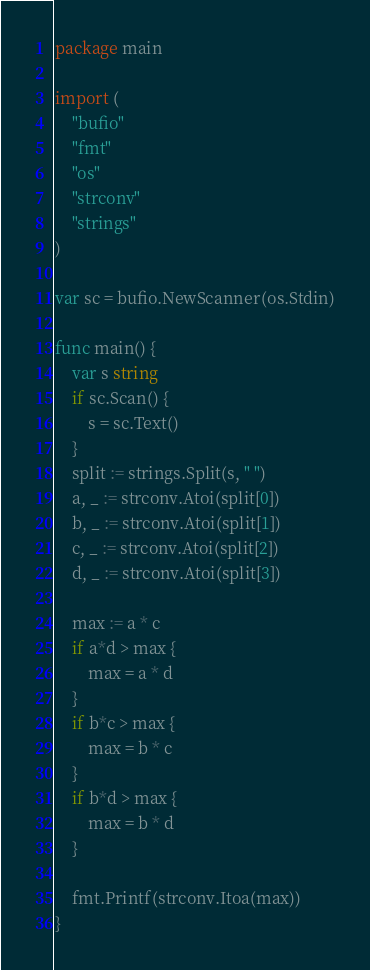Convert code to text. <code><loc_0><loc_0><loc_500><loc_500><_Go_>package main

import (
	"bufio"
	"fmt"
	"os"
	"strconv"
	"strings"
)

var sc = bufio.NewScanner(os.Stdin)

func main() {
	var s string
	if sc.Scan() {
		s = sc.Text()
	}
	split := strings.Split(s, " ")
	a, _ := strconv.Atoi(split[0])
	b, _ := strconv.Atoi(split[1])
	c, _ := strconv.Atoi(split[2])
	d, _ := strconv.Atoi(split[3])

	max := a * c
	if a*d > max {
		max = a * d
	}
	if b*c > max {
		max = b * c
	}
	if b*d > max {
		max = b * d
	}

	fmt.Printf(strconv.Itoa(max))
}
</code> 